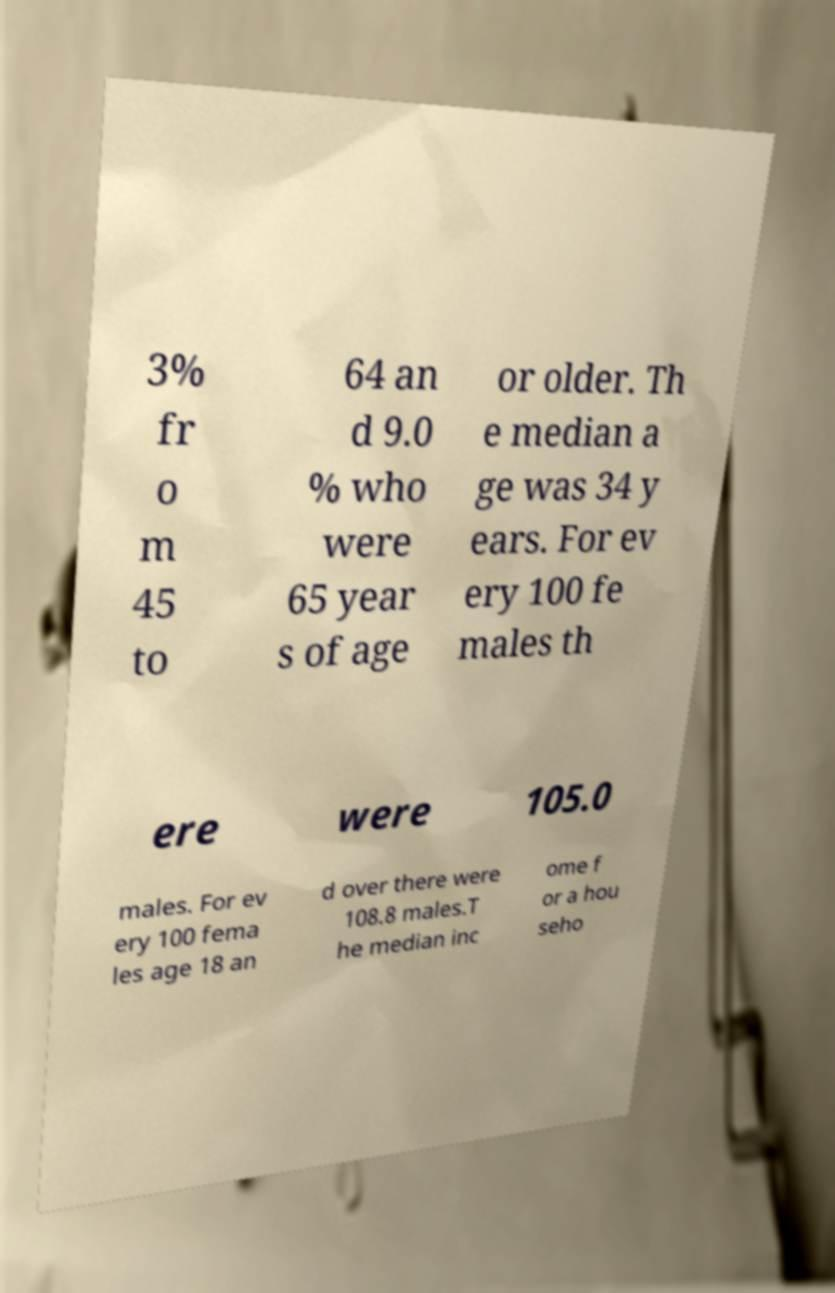There's text embedded in this image that I need extracted. Can you transcribe it verbatim? 3% fr o m 45 to 64 an d 9.0 % who were 65 year s of age or older. Th e median a ge was 34 y ears. For ev ery 100 fe males th ere were 105.0 males. For ev ery 100 fema les age 18 an d over there were 108.8 males.T he median inc ome f or a hou seho 